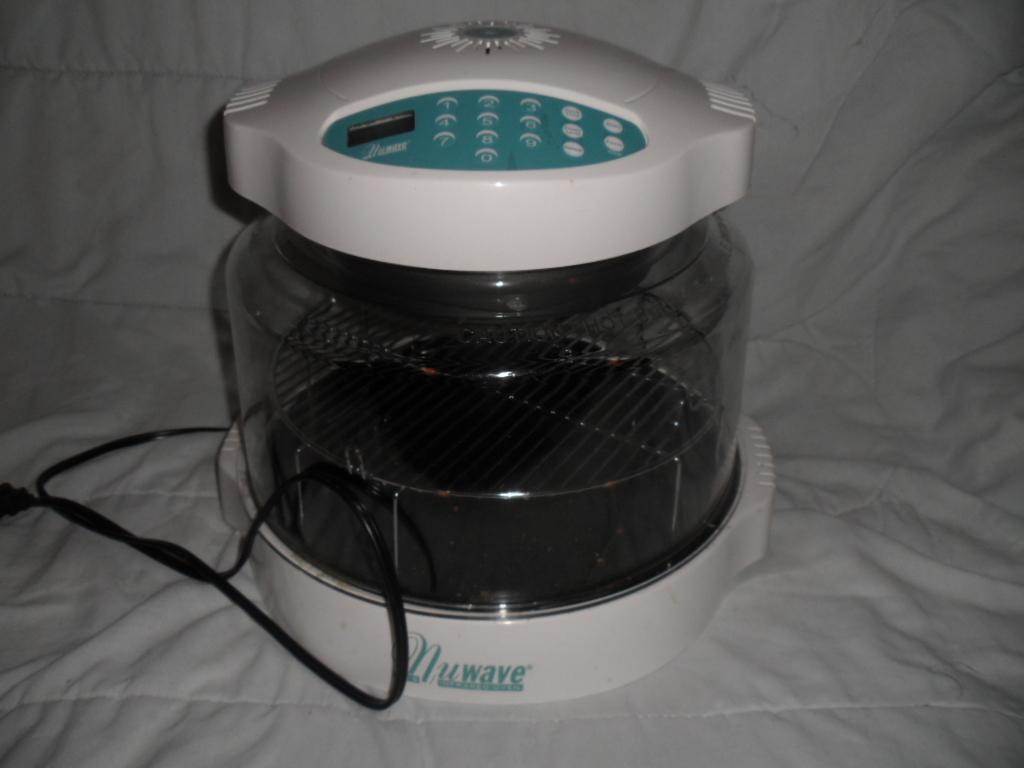Describe this image in one or two sentences. There is a device, which is having a wire, on the white color sheet. 